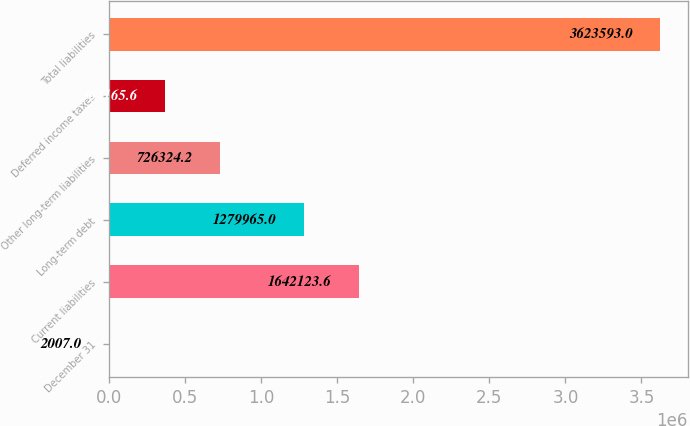Convert chart to OTSL. <chart><loc_0><loc_0><loc_500><loc_500><bar_chart><fcel>December 31<fcel>Current liabilities<fcel>Long-term debt<fcel>Other long-term liabilities<fcel>Deferred income taxes<fcel>Total liabilities<nl><fcel>2007<fcel>1.64212e+06<fcel>1.27996e+06<fcel>726324<fcel>364166<fcel>3.62359e+06<nl></chart> 